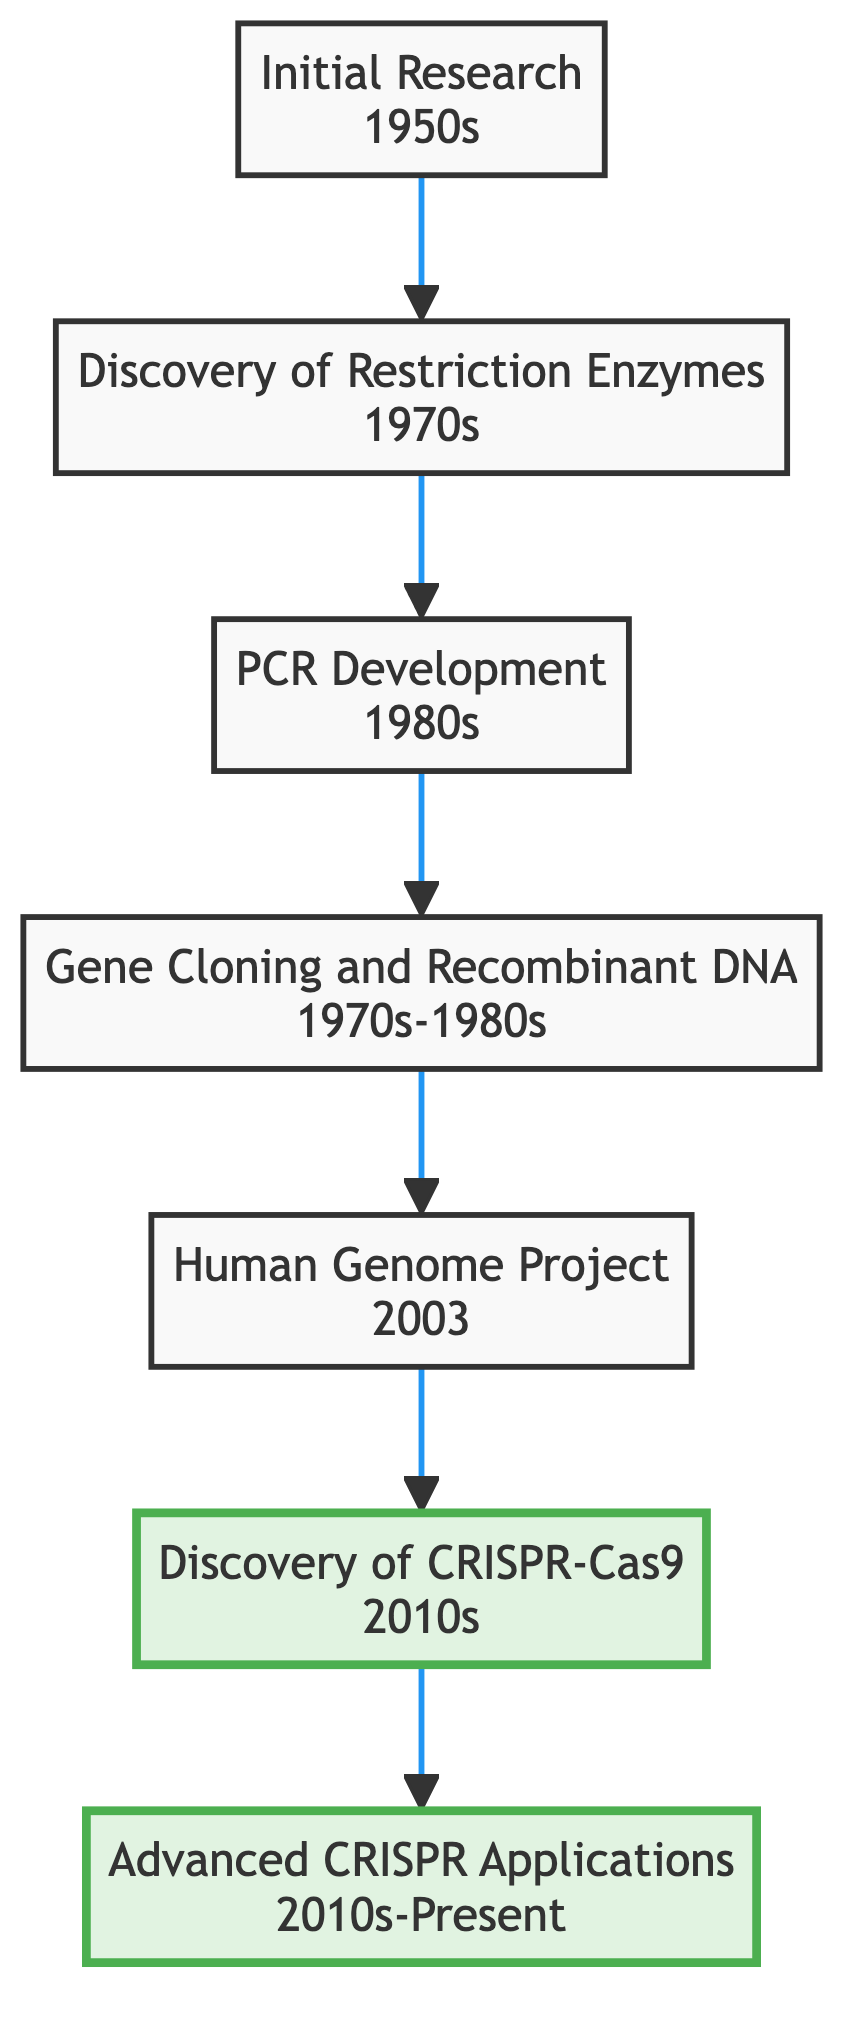What stage follows the Completion of Human Genome Project? The diagram shows a flow from the Completion of Human Genome Project to the Discovery of CRISPR-Cas9. Therefore, following that stage, the next one is the Discovery of CRISPR-Cas9.
Answer: Discovery of CRISPR-Cas9 What timeline is associated with the development of the Polymerase Chain Reaction? According to the diagram, the timeline for the Polymerase Chain Reaction Development is listed as the 1980s.
Answer: 1980s How many key entities are associated with the Initial Research stage? The Initial Research stage lists four key entities: James Watson, Francis Crick, Rosalind Franklin, and Maurice Wilkins. Therefore, there are four key entities.
Answer: Four What is the primary focus of Advanced CRISPR Applications? The Advanced CRISPR Applications stage in the diagram focuses on applying CRISPR-Cas9 for targeted genetic modifications in research and therapy.
Answer: Targeted genetic modifications Which stage occurs immediately before the Discovery of CRISPR-Cas9? The diagram indicates that the stage immediately before the Discovery of CRISPR-Cas9 is the Completion of Human Genome Project.
Answer: Completion of Human Genome Project Identify the key entities involved in the Discovery of CRISPR-Cas9. The key entities involved in the Discovery of CRISPR-Cas9, as displayed in the diagram, are Jennifer Doudna, Emmanuelle Charpentier, and Feng Zhang.
Answer: Jennifer Doudna, Emmanuelle Charpentier, Feng Zhang What major development occurred in the 1970s related to genetic tools? The diagram shows that the Discovery of Restriction Enzymes and Gene Cloning and Recombinant DNA Technology both occurred in the 1970s, highlighting their significance.
Answer: Discovery of Restriction Enzymes and Gene Cloning and Recombinant DNA Technology Which two major tools were developed before CRISPR-Cas9? The two major tools developed before CRISPR-Cas9 are the Polymerase Chain Reaction and Gene Cloning and Recombinant DNA Technology, as seen in their chronological order in the diagram.
Answer: Polymerase Chain Reaction and Gene Cloning and Recombinant DNA Technology What is the significance of the arrows pointing upwards in this flow chart? The arrows pointing upwards indicate the progression and evolution of genetic editing tools through various developmental stages, culminating in the CRISPR applications at the top.
Answer: Progression of genetic editing tools 